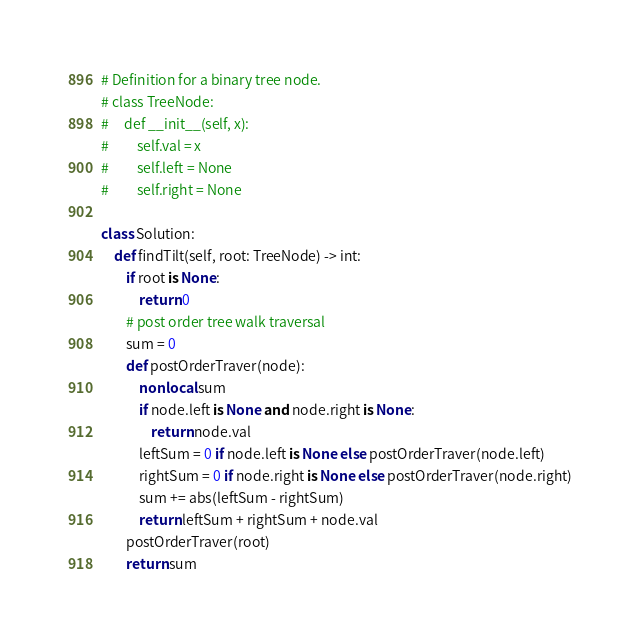Convert code to text. <code><loc_0><loc_0><loc_500><loc_500><_Python_># Definition for a binary tree node.
# class TreeNode:
#     def __init__(self, x):
#         self.val = x
#         self.left = None
#         self.right = None

class Solution:
    def findTilt(self, root: TreeNode) -> int:
        if root is None:
            return 0
        # post order tree walk traversal
        sum = 0
        def postOrderTraver(node):
            nonlocal sum
            if node.left is None and node.right is None:
                return node.val
            leftSum = 0 if node.left is None else postOrderTraver(node.left)
            rightSum = 0 if node.right is None else postOrderTraver(node.right)
            sum += abs(leftSum - rightSum)
            return leftSum + rightSum + node.val
        postOrderTraver(root)
        return sum</code> 